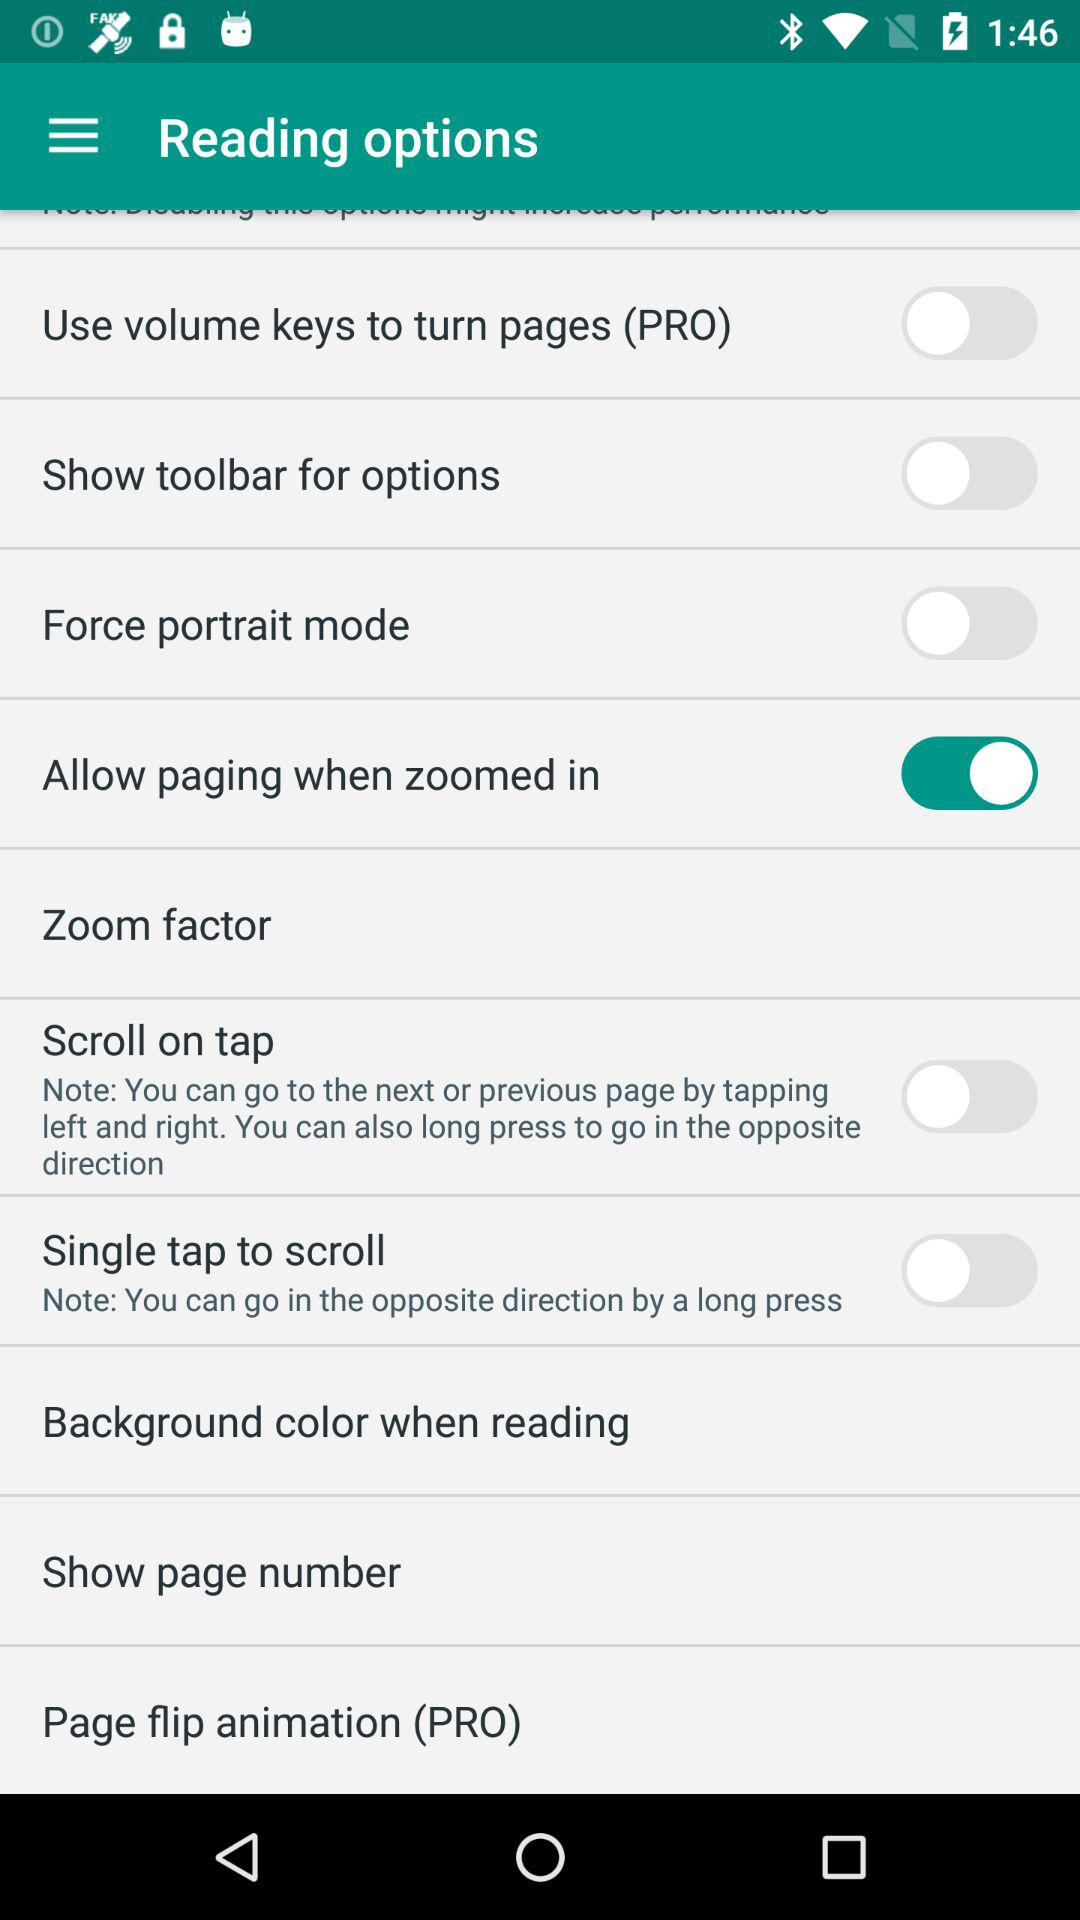Which background colors are available?
When the provided information is insufficient, respond with <no answer>. <no answer> 